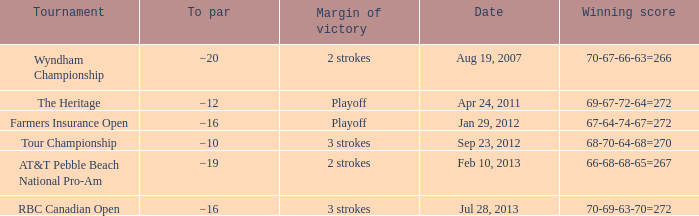What is the to par of the match with a winning score 69-67-72-64=272? −12. 